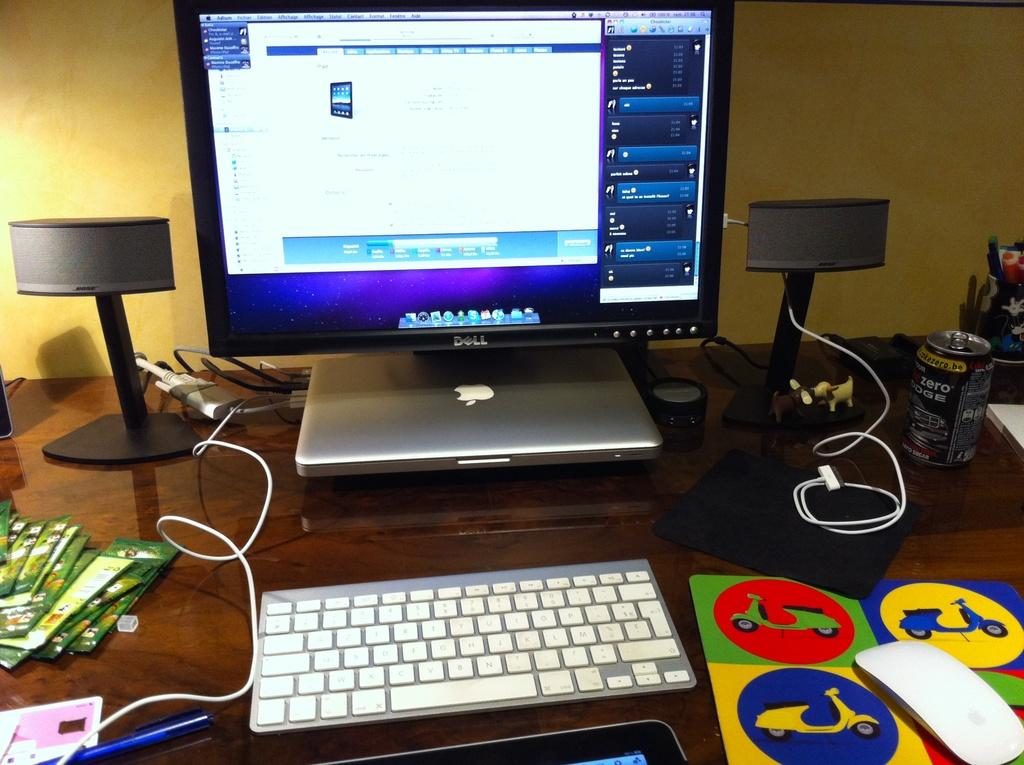What type of device is on the table in the image? There is a keyboard on the table. What other electronic device can be seen on the table? There is a monitor on the table. What additional computing device is present on the table? There is a laptop on the table. What is used for amplifying sound in the image? There is a sound box on the table. What is the small cylindrical object on the table? There is a tin on the table. What type of play items are on the table? There are toys on the table. What is used for controlling the cursor on the screen in the image? There is a mouse on the table. What is used for writing in the image? There is a pen on the table. What type of trail can be seen coming from the laptop in the image? There is no trail coming from the laptop in the image. What type of operation is being performed on the lettuce in the image? There is no lettuce present in the image. 